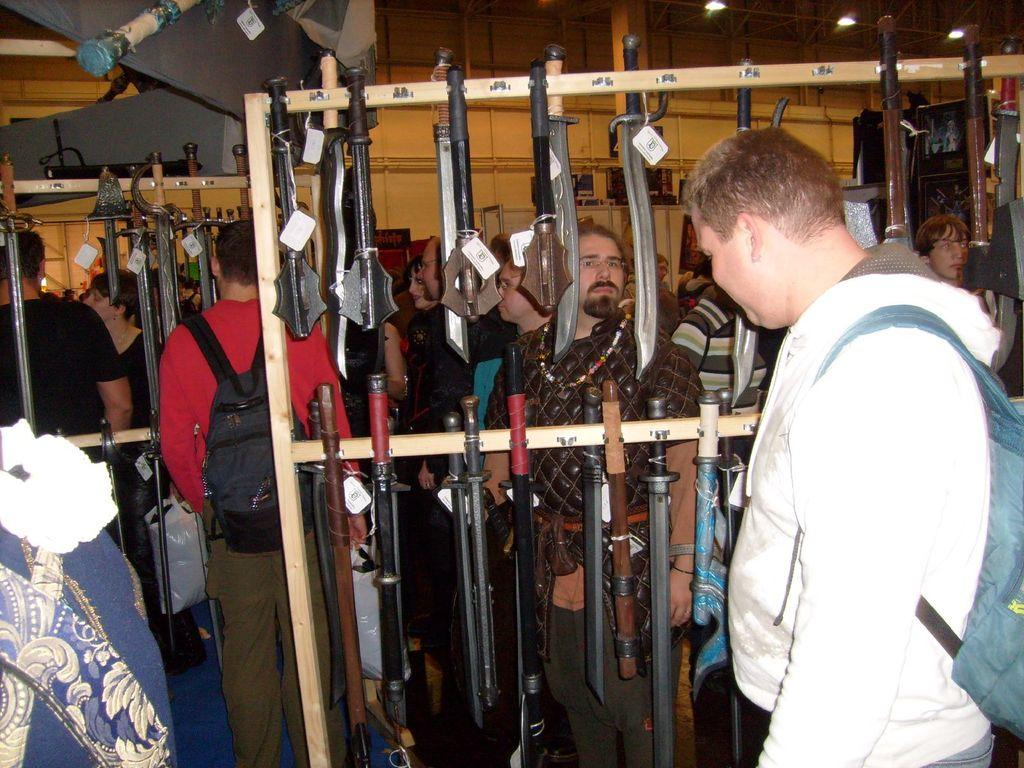What is happening in the image involving a group of people? There is a group of people in the image, and they are carrying bags. What are the people doing in the image? The people are standing in the image. What objects can be seen in the image related to the group of people? There are swords in the image. What can be seen in the background of the image? There is a wall in the background of the image. What type of shade is being used to protect the group of people from the sun in the image? There is no shade present in the image to protect the group of people from the sun. What meal are the people eating in the image? There is no meal being eaten in the image; the people are carrying bags and standing with swords. 